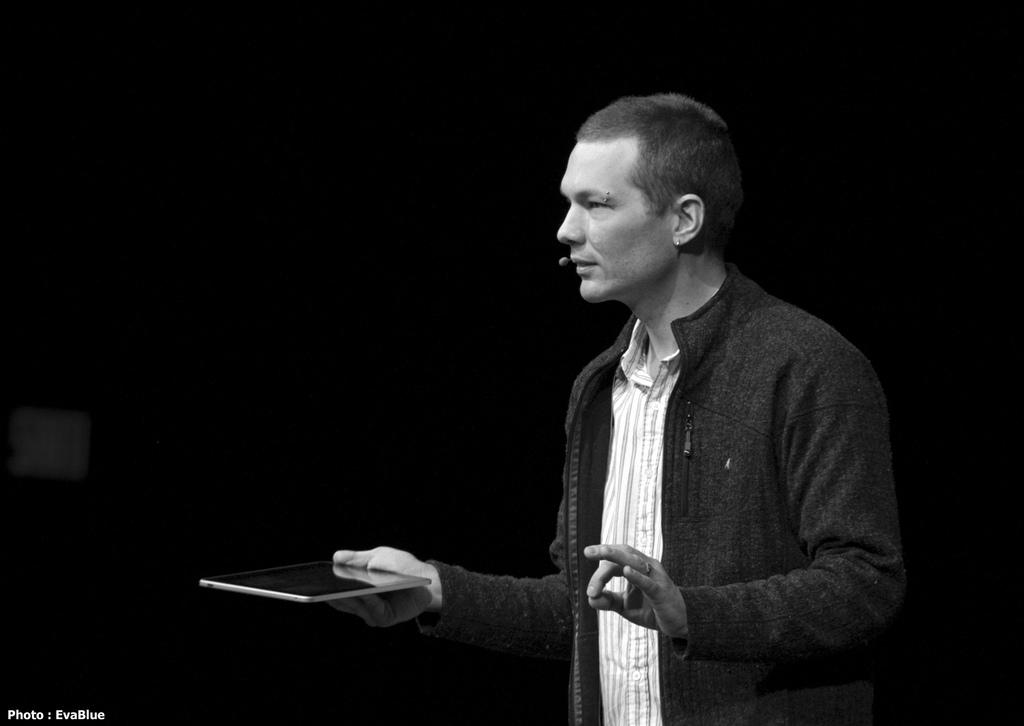Who is present in the image? There is a man in the image. What is the man doing in the image? The man is standing in the image. What is the man holding in the image? The man is holding an electronic device in the image. How many fingers can be seen on the man's left hand in the image? There is no information about the man's fingers in the image, so it cannot be determined. 